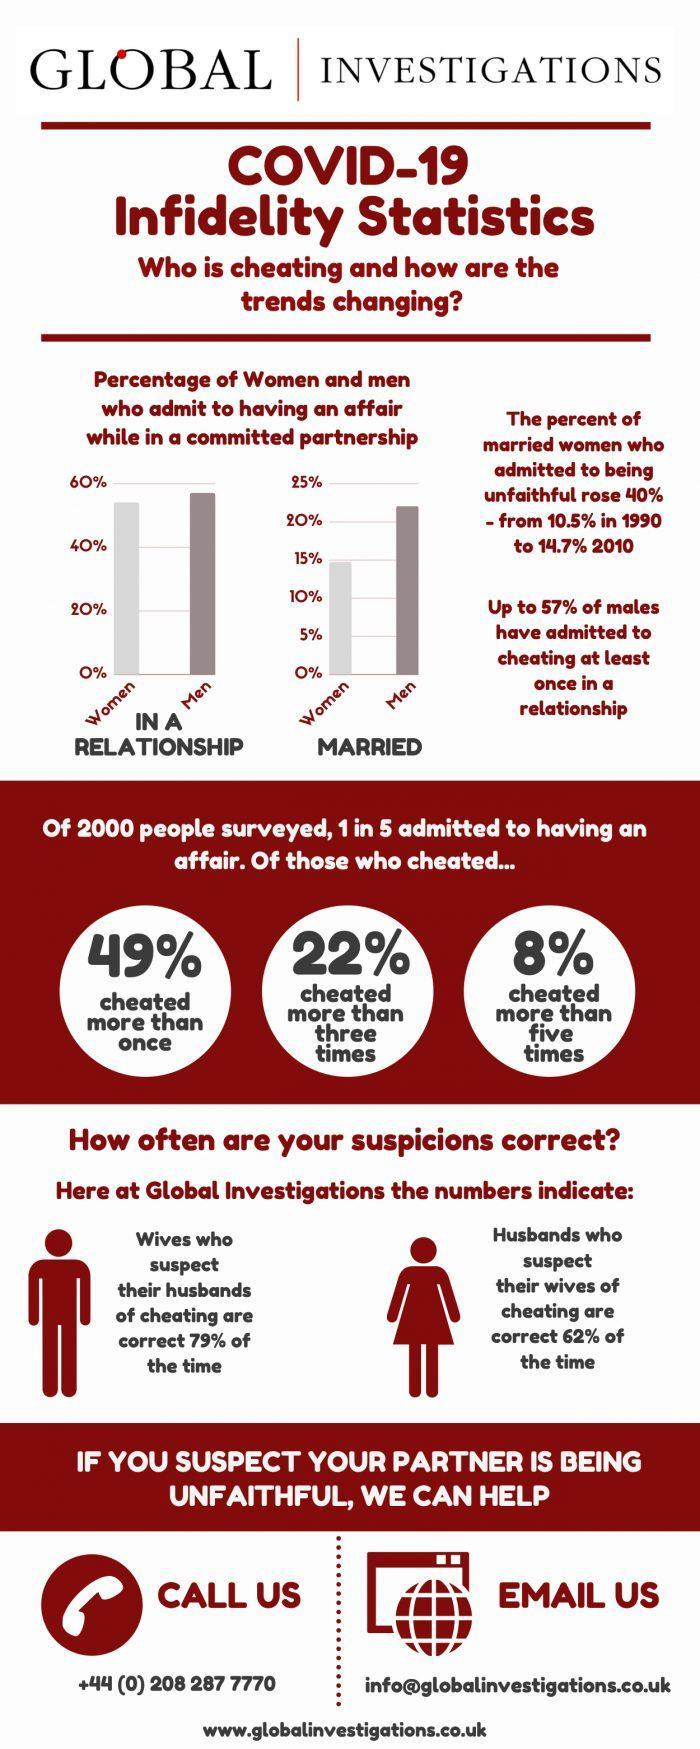What percentage of 2000 people surveyed, admitted to having an affair?
Answer the question with a short phrase. 20% What percent of husbands who suspect their wives of cheating are correct? 62% What percent of wives who suspect their husbands of cheating are correct? 79% 